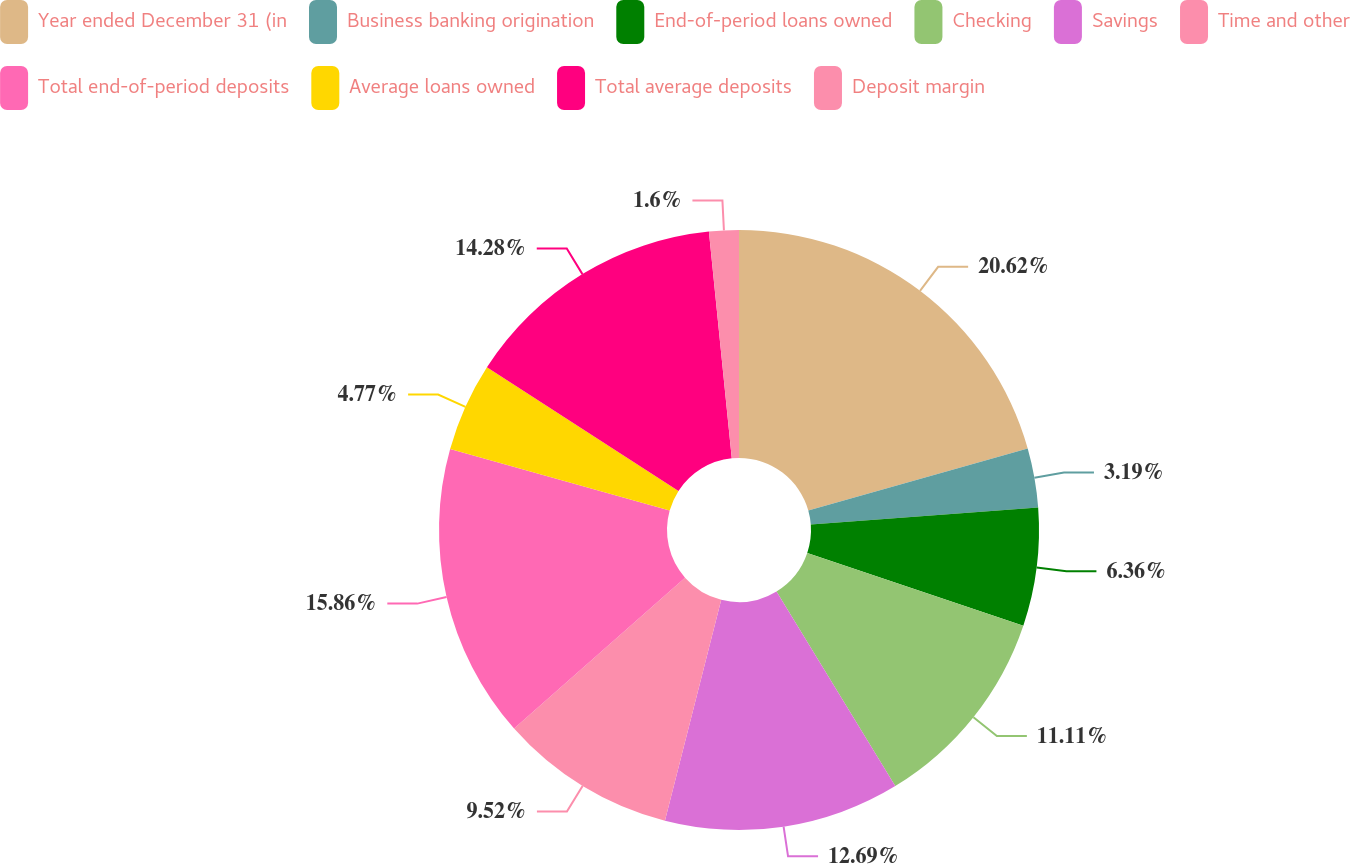<chart> <loc_0><loc_0><loc_500><loc_500><pie_chart><fcel>Year ended December 31 (in<fcel>Business banking origination<fcel>End-of-period loans owned<fcel>Checking<fcel>Savings<fcel>Time and other<fcel>Total end-of-period deposits<fcel>Average loans owned<fcel>Total average deposits<fcel>Deposit margin<nl><fcel>20.62%<fcel>3.19%<fcel>6.36%<fcel>11.11%<fcel>12.69%<fcel>9.52%<fcel>15.86%<fcel>4.77%<fcel>14.28%<fcel>1.6%<nl></chart> 